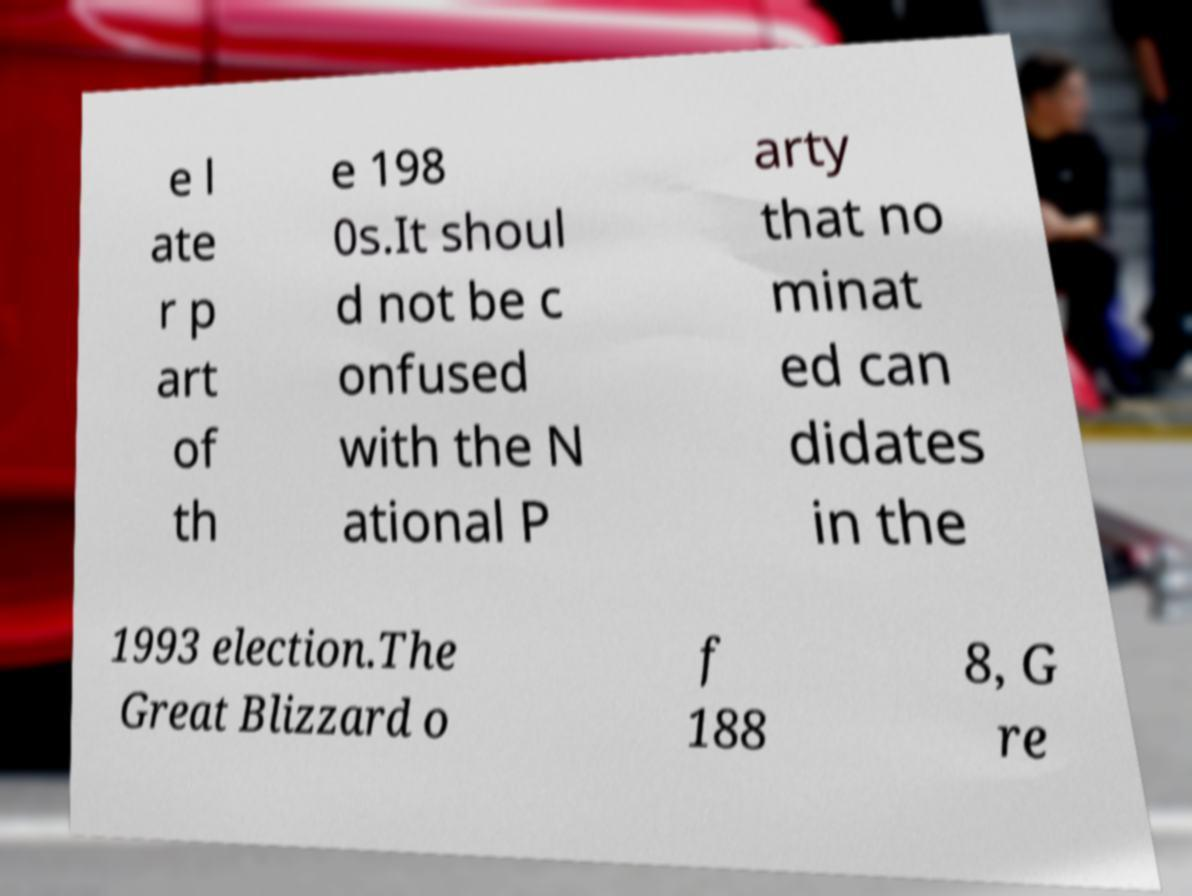Could you extract and type out the text from this image? e l ate r p art of th e 198 0s.It shoul d not be c onfused with the N ational P arty that no minat ed can didates in the 1993 election.The Great Blizzard o f 188 8, G re 